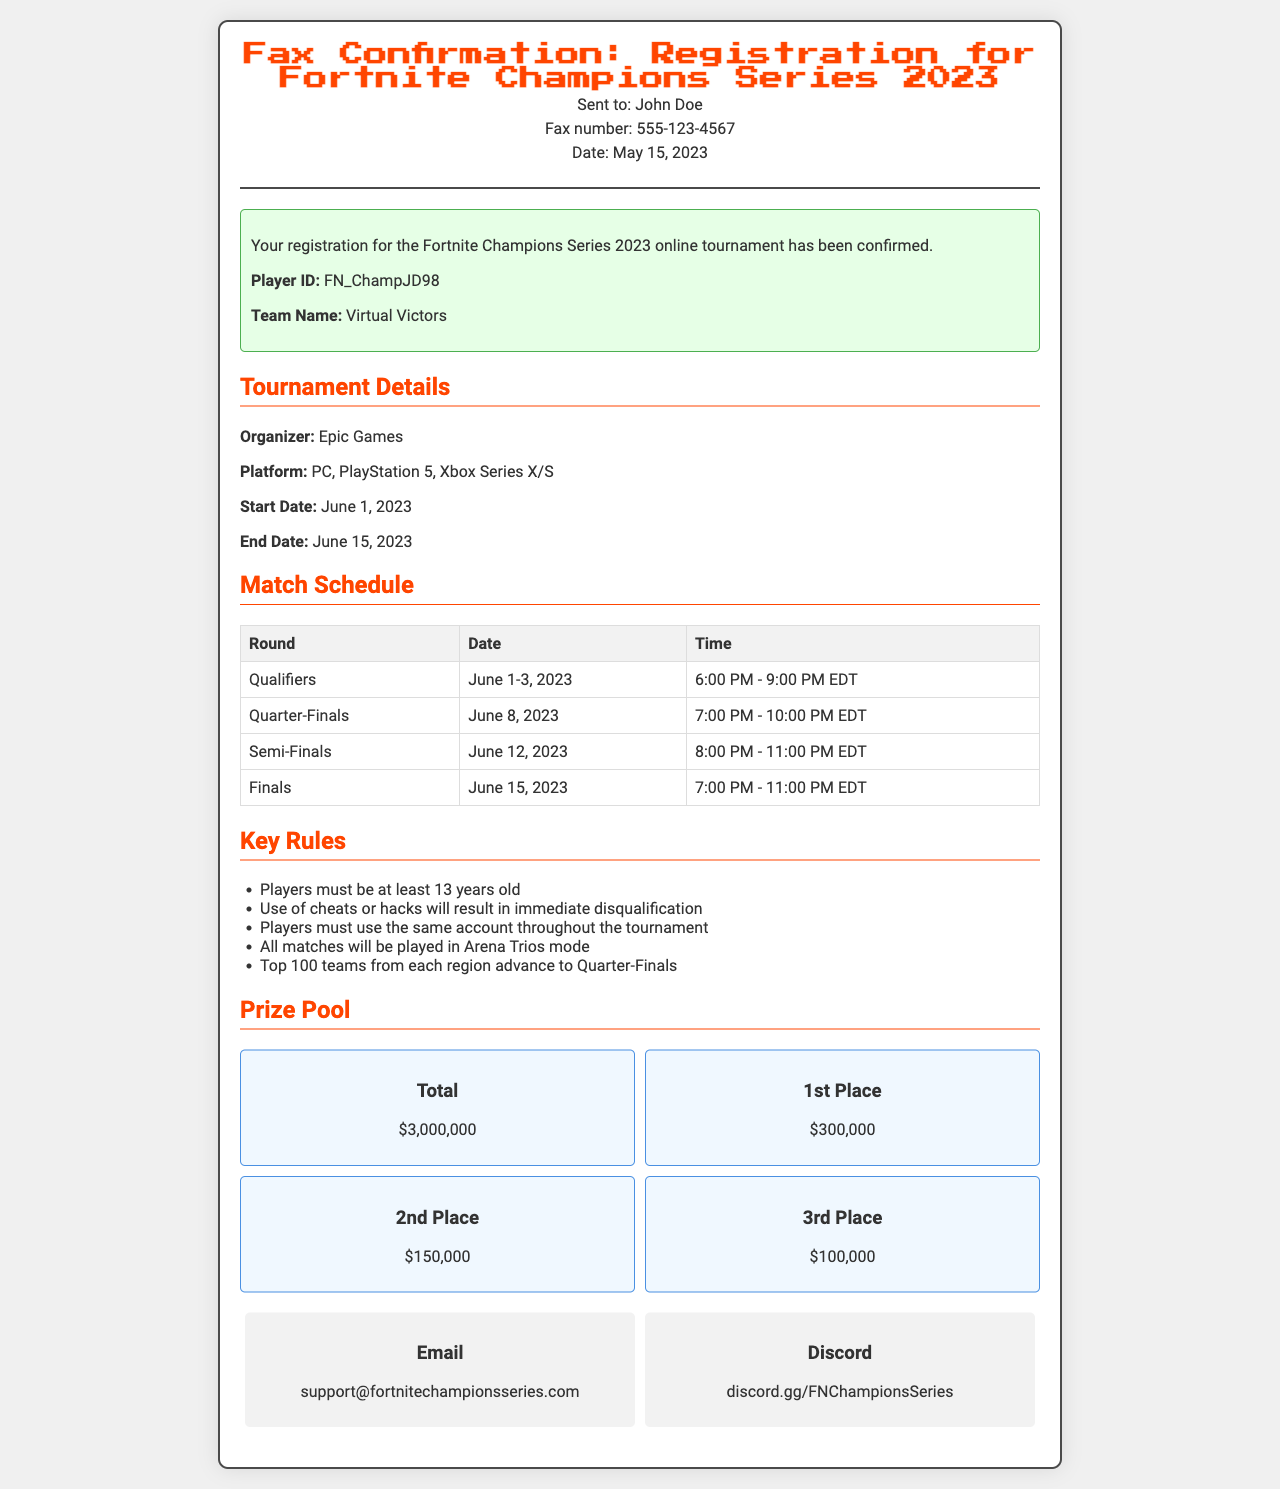What is the tournament name? The tournament name is indicated at the top of the document in the title.
Answer: Fortnite Champions Series 2023 What is the player ID? The player ID is mentioned in the confirmation section of the document.
Answer: FN_ChampJD98 What are the start and end dates of the tournament? The start and end dates can be found in the tournament details section.
Answer: June 1, 2023 - June 15, 2023 Which platform(s) are allowed for the tournament? The platform information is provided in the tournament details.
Answer: PC, PlayStation 5, Xbox Series X/S What is the prize for the 2nd place? The prize for 2nd place is listed in the prize pool section.
Answer: $150,000 What is the age requirement for players? The age requirement is outlined in the key rules section of the document.
Answer: 13 years old What is the date and time for the Semi-Finals? The date and time for the Semi-Finals are provided within the match schedule table.
Answer: June 12, 2023, 8:00 PM - 11:00 PM EDT What happens if a player uses cheats? The consequences for using cheats are specified in the key rules of the document.
Answer: Disqualification What is the total prize pool? The total prize pool is found in the prize pool section.
Answer: $3,000,000 